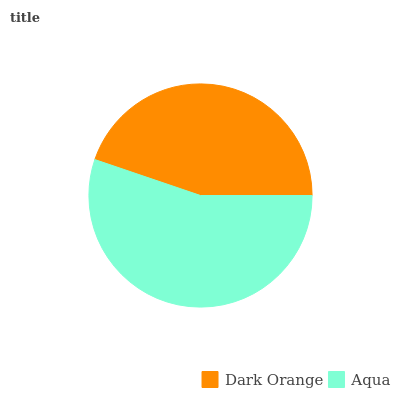Is Dark Orange the minimum?
Answer yes or no. Yes. Is Aqua the maximum?
Answer yes or no. Yes. Is Aqua the minimum?
Answer yes or no. No. Is Aqua greater than Dark Orange?
Answer yes or no. Yes. Is Dark Orange less than Aqua?
Answer yes or no. Yes. Is Dark Orange greater than Aqua?
Answer yes or no. No. Is Aqua less than Dark Orange?
Answer yes or no. No. Is Aqua the high median?
Answer yes or no. Yes. Is Dark Orange the low median?
Answer yes or no. Yes. Is Dark Orange the high median?
Answer yes or no. No. Is Aqua the low median?
Answer yes or no. No. 